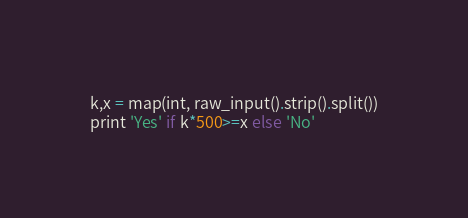<code> <loc_0><loc_0><loc_500><loc_500><_Python_>k,x = map(int, raw_input().strip().split())
print 'Yes' if k*500>=x else 'No'
</code> 